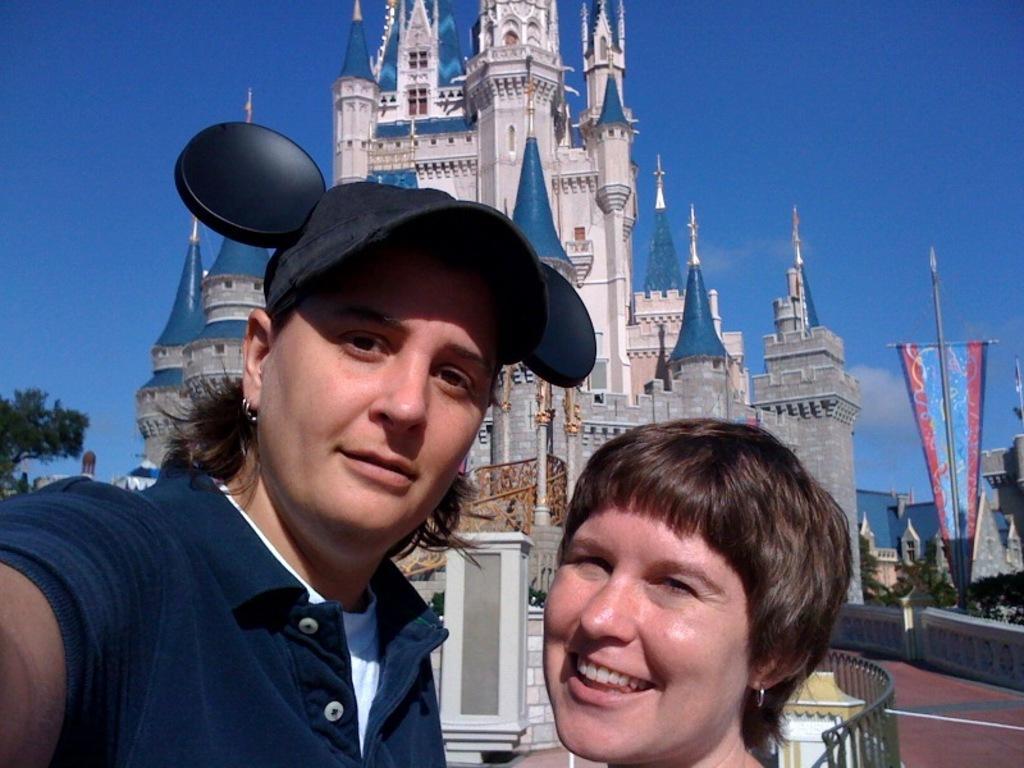Could you give a brief overview of what you see in this image? In this picture we can see two women, behind we can see building and trees. 